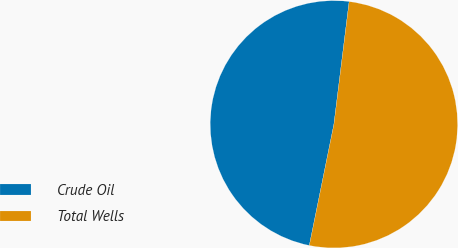<chart> <loc_0><loc_0><loc_500><loc_500><pie_chart><fcel>Crude Oil<fcel>Total Wells<nl><fcel>48.78%<fcel>51.22%<nl></chart> 